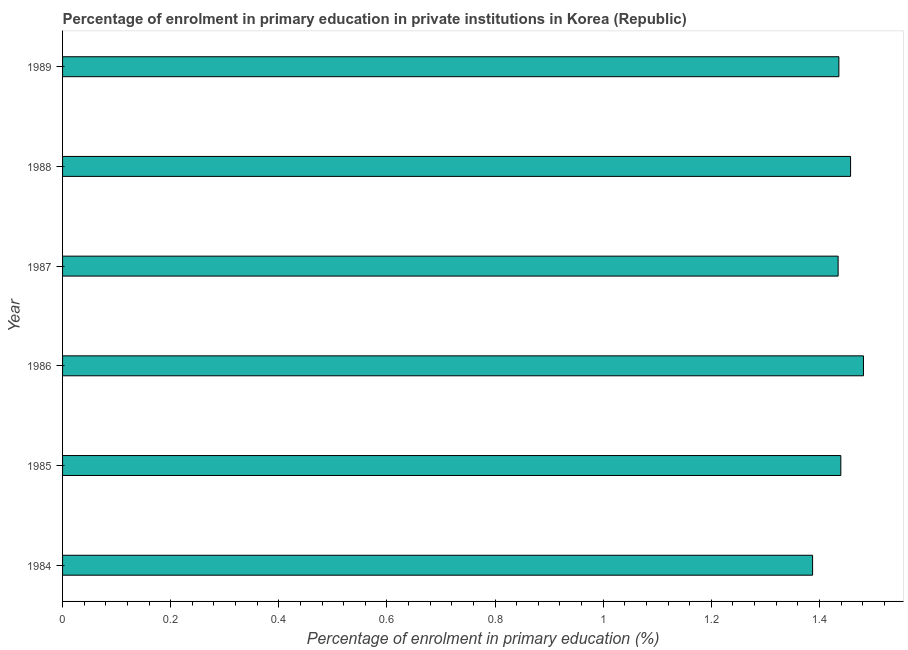What is the title of the graph?
Make the answer very short. Percentage of enrolment in primary education in private institutions in Korea (Republic). What is the label or title of the X-axis?
Give a very brief answer. Percentage of enrolment in primary education (%). What is the label or title of the Y-axis?
Ensure brevity in your answer.  Year. What is the enrolment percentage in primary education in 1986?
Provide a succinct answer. 1.48. Across all years, what is the maximum enrolment percentage in primary education?
Your response must be concise. 1.48. Across all years, what is the minimum enrolment percentage in primary education?
Your answer should be compact. 1.39. In which year was the enrolment percentage in primary education maximum?
Ensure brevity in your answer.  1986. In which year was the enrolment percentage in primary education minimum?
Provide a short and direct response. 1984. What is the sum of the enrolment percentage in primary education?
Your answer should be compact. 8.64. What is the difference between the enrolment percentage in primary education in 1986 and 1989?
Give a very brief answer. 0.04. What is the average enrolment percentage in primary education per year?
Offer a terse response. 1.44. What is the median enrolment percentage in primary education?
Give a very brief answer. 1.44. Do a majority of the years between 1987 and 1984 (inclusive) have enrolment percentage in primary education greater than 0.44 %?
Ensure brevity in your answer.  Yes. Is the enrolment percentage in primary education in 1987 less than that in 1989?
Offer a very short reply. Yes. What is the difference between the highest and the second highest enrolment percentage in primary education?
Your answer should be very brief. 0.02. Is the sum of the enrolment percentage in primary education in 1985 and 1987 greater than the maximum enrolment percentage in primary education across all years?
Give a very brief answer. Yes. What is the difference between the highest and the lowest enrolment percentage in primary education?
Offer a terse response. 0.09. How many bars are there?
Make the answer very short. 6. Are all the bars in the graph horizontal?
Offer a very short reply. Yes. What is the difference between two consecutive major ticks on the X-axis?
Your answer should be compact. 0.2. What is the Percentage of enrolment in primary education (%) of 1984?
Give a very brief answer. 1.39. What is the Percentage of enrolment in primary education (%) of 1985?
Make the answer very short. 1.44. What is the Percentage of enrolment in primary education (%) in 1986?
Provide a short and direct response. 1.48. What is the Percentage of enrolment in primary education (%) of 1987?
Offer a terse response. 1.43. What is the Percentage of enrolment in primary education (%) in 1988?
Provide a succinct answer. 1.46. What is the Percentage of enrolment in primary education (%) in 1989?
Offer a terse response. 1.44. What is the difference between the Percentage of enrolment in primary education (%) in 1984 and 1985?
Keep it short and to the point. -0.05. What is the difference between the Percentage of enrolment in primary education (%) in 1984 and 1986?
Keep it short and to the point. -0.09. What is the difference between the Percentage of enrolment in primary education (%) in 1984 and 1987?
Keep it short and to the point. -0.05. What is the difference between the Percentage of enrolment in primary education (%) in 1984 and 1988?
Offer a very short reply. -0.07. What is the difference between the Percentage of enrolment in primary education (%) in 1984 and 1989?
Provide a short and direct response. -0.05. What is the difference between the Percentage of enrolment in primary education (%) in 1985 and 1986?
Your response must be concise. -0.04. What is the difference between the Percentage of enrolment in primary education (%) in 1985 and 1987?
Offer a terse response. 0.01. What is the difference between the Percentage of enrolment in primary education (%) in 1985 and 1988?
Your answer should be compact. -0.02. What is the difference between the Percentage of enrolment in primary education (%) in 1985 and 1989?
Ensure brevity in your answer.  0. What is the difference between the Percentage of enrolment in primary education (%) in 1986 and 1987?
Give a very brief answer. 0.05. What is the difference between the Percentage of enrolment in primary education (%) in 1986 and 1988?
Keep it short and to the point. 0.02. What is the difference between the Percentage of enrolment in primary education (%) in 1986 and 1989?
Your answer should be compact. 0.05. What is the difference between the Percentage of enrolment in primary education (%) in 1987 and 1988?
Ensure brevity in your answer.  -0.02. What is the difference between the Percentage of enrolment in primary education (%) in 1987 and 1989?
Provide a succinct answer. -0. What is the difference between the Percentage of enrolment in primary education (%) in 1988 and 1989?
Your answer should be very brief. 0.02. What is the ratio of the Percentage of enrolment in primary education (%) in 1984 to that in 1985?
Offer a terse response. 0.96. What is the ratio of the Percentage of enrolment in primary education (%) in 1984 to that in 1986?
Provide a short and direct response. 0.94. What is the ratio of the Percentage of enrolment in primary education (%) in 1984 to that in 1989?
Your response must be concise. 0.97. What is the ratio of the Percentage of enrolment in primary education (%) in 1985 to that in 1986?
Offer a very short reply. 0.97. What is the ratio of the Percentage of enrolment in primary education (%) in 1985 to that in 1987?
Offer a very short reply. 1. What is the ratio of the Percentage of enrolment in primary education (%) in 1985 to that in 1988?
Offer a terse response. 0.99. What is the ratio of the Percentage of enrolment in primary education (%) in 1985 to that in 1989?
Give a very brief answer. 1. What is the ratio of the Percentage of enrolment in primary education (%) in 1986 to that in 1987?
Ensure brevity in your answer.  1.03. What is the ratio of the Percentage of enrolment in primary education (%) in 1986 to that in 1988?
Your answer should be very brief. 1.02. What is the ratio of the Percentage of enrolment in primary education (%) in 1986 to that in 1989?
Give a very brief answer. 1.03. What is the ratio of the Percentage of enrolment in primary education (%) in 1987 to that in 1988?
Your response must be concise. 0.98. 